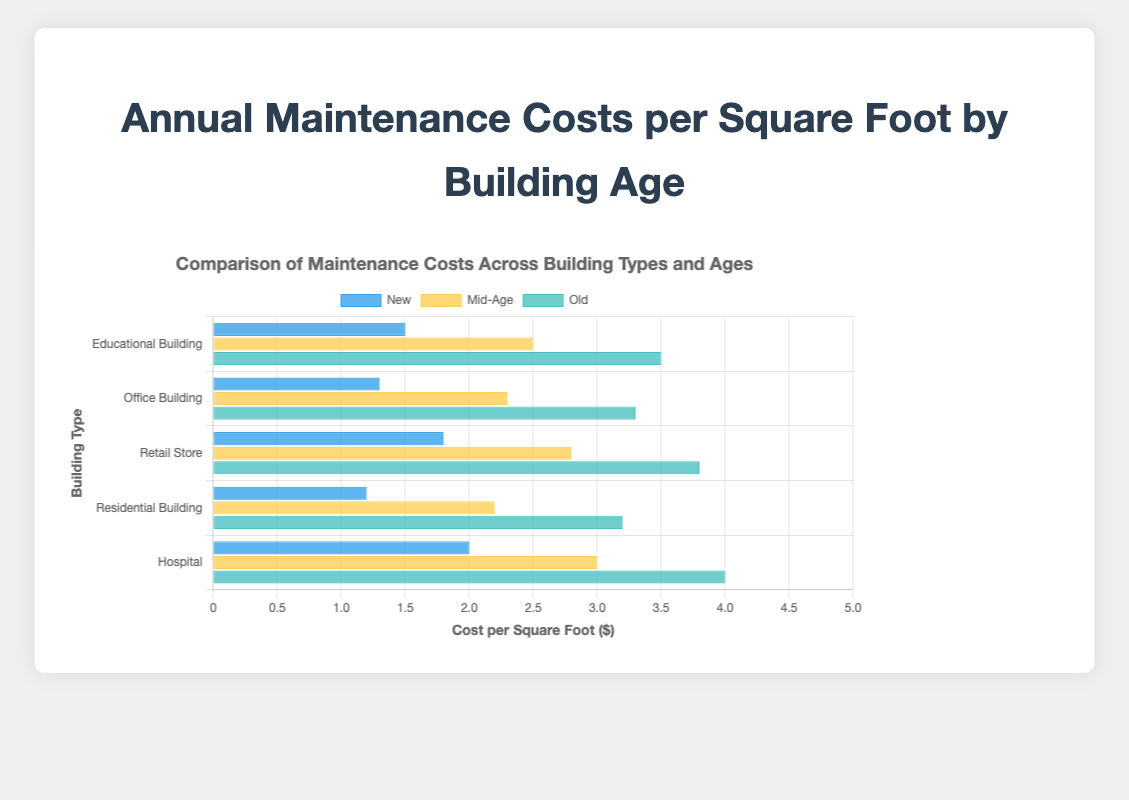Which building type has the highest annual maintenance cost per square foot for new buildings? Observing the bars for "New" building age, the highest bar corresponds to "Hospital" which is at $2.0 per square foot.
Answer: Hospital How do the maintenance costs of mid-age educational buildings compare to mid-age residential buildings? For mid-age buildings, the cost for "Educational Buildings" is $2.5 per square foot and for "Residential Buildings," it is $2.2 per square foot. Therefore, mid-age educational buildings have higher maintenance costs.
Answer: Educational buildings have higher costs What is the difference in maintenance costs per square foot between old office buildings and new educational buildings? The cost for old office buildings is $3.3 per square foot and for new educational buildings, it is $1.5 per square foot. The difference is $3.3 - $1.5 = $1.8.
Answer: $1.8 Which age group has the lowest maintenance costs for retail stores? Observing the bars for "Retail Store" across different age groups, new buildings have the lowest cost at $1.8 per square foot.
Answer: New What is the average maintenance cost per square foot for hospitals across all age groups? The costs are: New at $2.0, Mid-Age at $3.0, and Old at $4.0. The average is calculated as (2.0 + 3.0 + 4.0) / 3 = 3.0.
Answer: $3.0 Is the maintenance cost of a mid-age retail store higher or lower than an old residential building? The mid-age retail store costs $2.8 per square foot, while the old residential building costs $3.2 per square foot. Therefore, the mid-age retail store is lower in cost.
Answer: Lower Which building type shows the most significant increase in maintenance costs per square foot from new to old? Examining the increase for each type: 
- Educational from $1.5 to $3.5 (increase of $2.0)
- Office from $1.3 to $3.3 (increase of $2.0)
- Retail from $1.8 to $3.8 (increase of $2.0)
- Residential from $1.2 to $3.2 (increase of $2.0)
- Hospital from $2.0 to $4.0 (increase of $2.0).
Each type has the same increase of $2.0 except the hospital which also increases by $2.0.
Thus they all have the same significant increase.
Answer: All building types show the same increase How does the visual length of old educational buildings compare to mid-age office buildings? The bar representing old educational buildings is longer than the bar for mid-age office buildings, indicating higher maintenance costs for the former.
Answer: Longer What is the total maintenance cost for new educational, office, and retail buildings combined? Adding the costs for new educational ($1.5), new office ($1.3), and new retail ($1.8) buildings results in $1.5 + $1.3 + $1.8 = $4.6.
Answer: $4.6 For new buildings, which type has a maintenance cost lower than the mid-age educational building but higher than the mid-age residential building? The mid-age residential building costs $2.2 and the mid-age educational building costs $2.5. For new buildings:
- Educational is $1.5
- Office is $1.3
- Retail is $1.8
- Residential is $1.2
- Hospital is $2.0.
The hospital new building with $2.0 fits this condition.
Answer: Hospital 